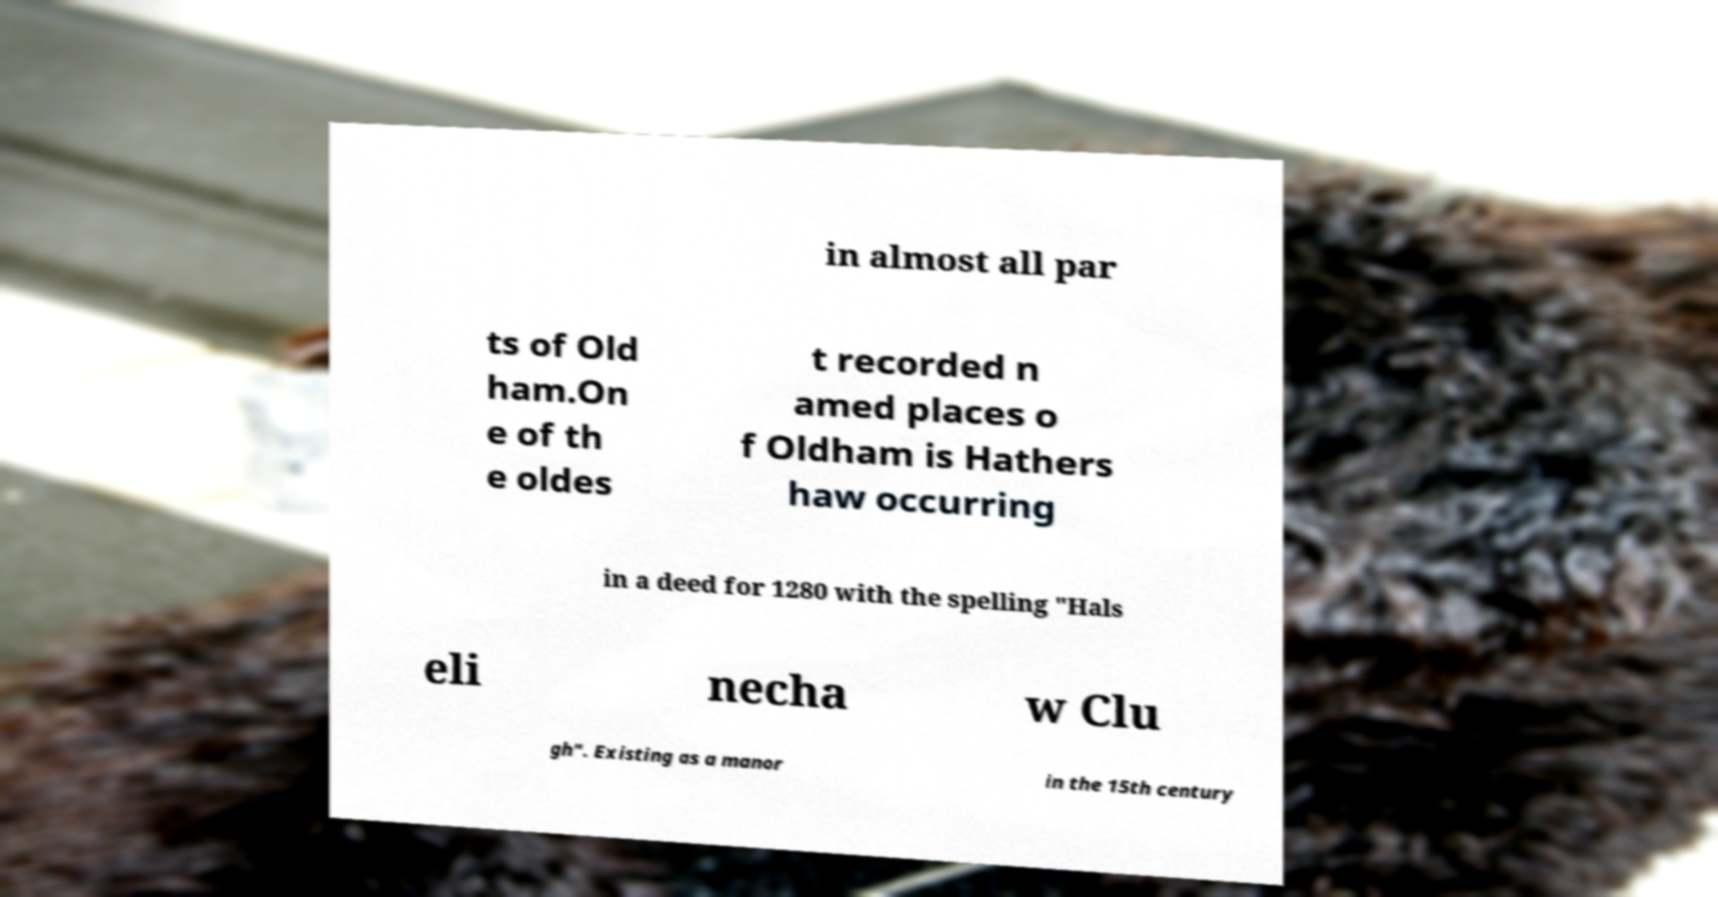For documentation purposes, I need the text within this image transcribed. Could you provide that? in almost all par ts of Old ham.On e of th e oldes t recorded n amed places o f Oldham is Hathers haw occurring in a deed for 1280 with the spelling "Hals eli necha w Clu gh". Existing as a manor in the 15th century 